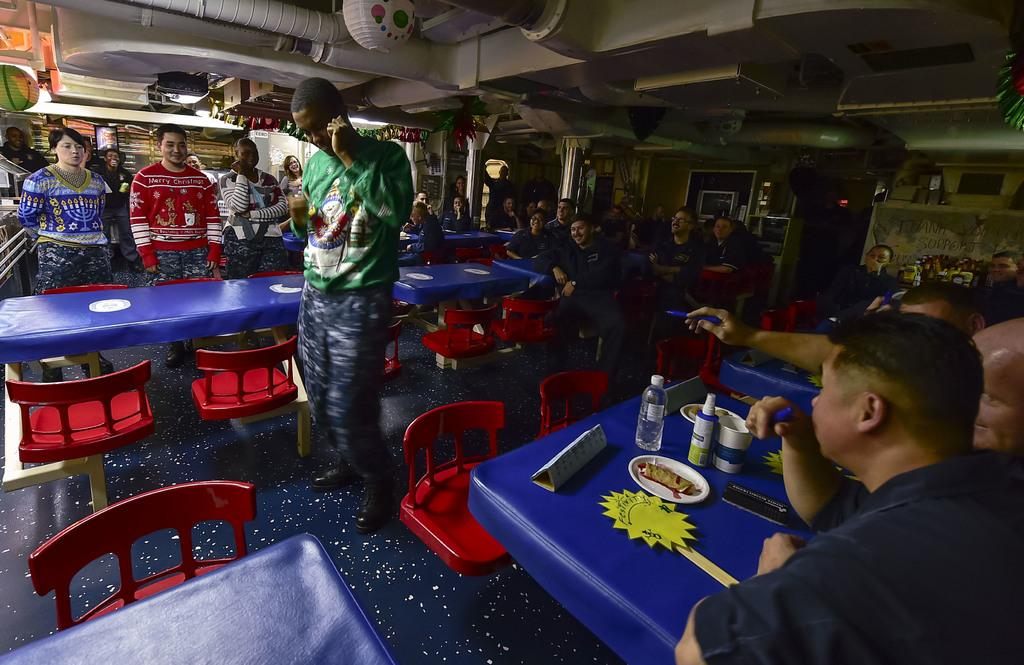What can be seen in the image? There are people, tables, chairs, and food items in the image. What is present in the background of the image? There is a wall, a television, paintings, and posters in the background of the image. What type of jewel is being worn by the people in the image? There is no mention of any jewelry or jewels being worn by the people in the image. How do the people in the image say good-bye to each other? The image does not depict any interactions between the people, so it is impossible to determine how they say good-bye to each other. 